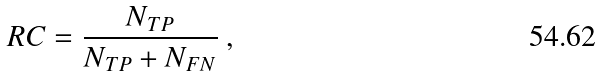<formula> <loc_0><loc_0><loc_500><loc_500>R C = \frac { N _ { T P } } { N _ { T P } + N _ { F N } } \ ,</formula> 